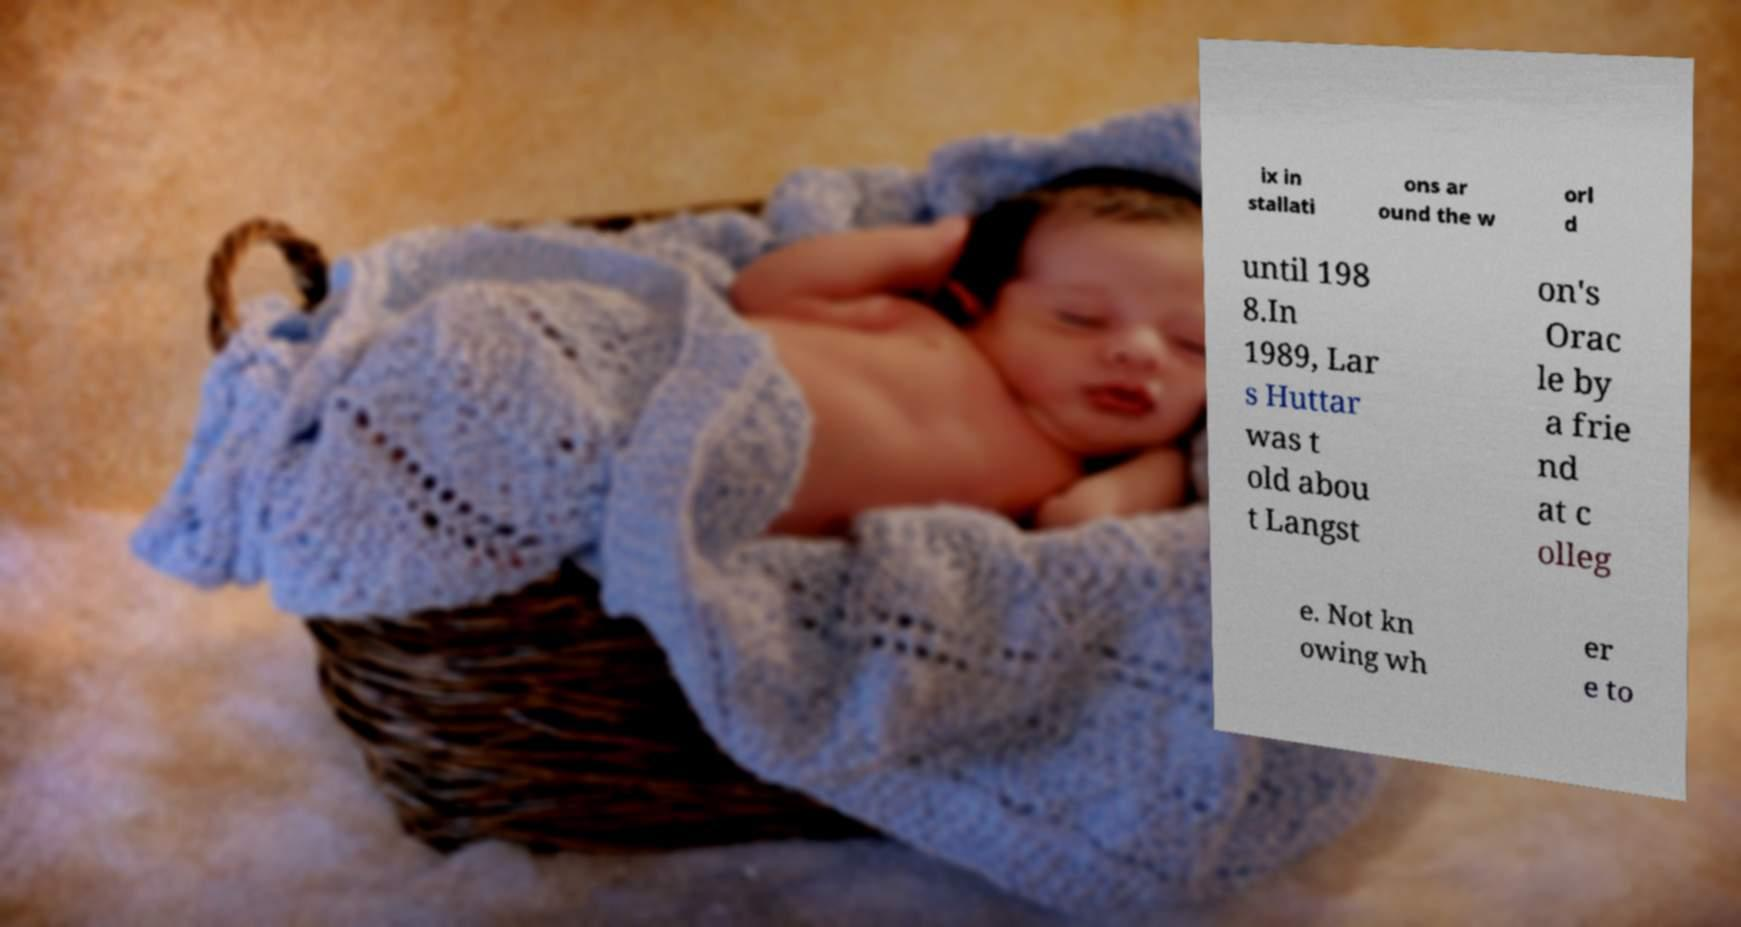Can you read and provide the text displayed in the image?This photo seems to have some interesting text. Can you extract and type it out for me? ix in stallati ons ar ound the w orl d until 198 8.In 1989, Lar s Huttar was t old abou t Langst on's Orac le by a frie nd at c olleg e. Not kn owing wh er e to 